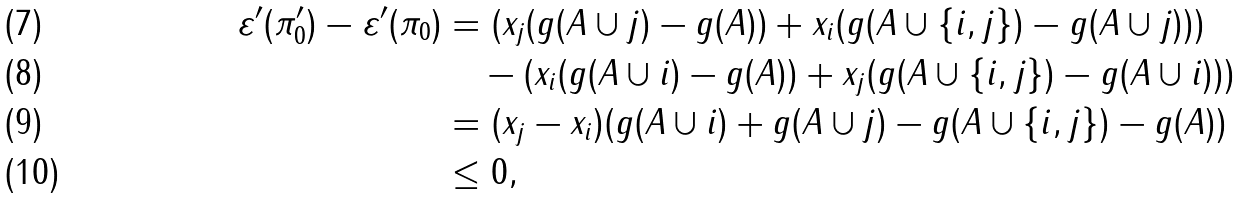Convert formula to latex. <formula><loc_0><loc_0><loc_500><loc_500>\varepsilon ^ { \prime } ( \pi _ { 0 } ^ { \prime } ) - \varepsilon ^ { \prime } ( \pi _ { 0 } ) & = ( x _ { j } ( g ( A \cup j ) - g ( A ) ) + x _ { i } ( g ( A \cup \{ i , j \} ) - g ( A \cup j ) ) ) \\ & \quad - ( x _ { i } ( g ( A \cup i ) - g ( A ) ) + x _ { j } ( g ( A \cup \{ i , j \} ) - g ( A \cup i ) ) ) \\ & = ( x _ { j } - x _ { i } ) ( g ( A \cup i ) + g ( A \cup j ) - g ( A \cup \{ i , j \} ) - g ( A ) ) \\ & \leq 0 ,</formula> 